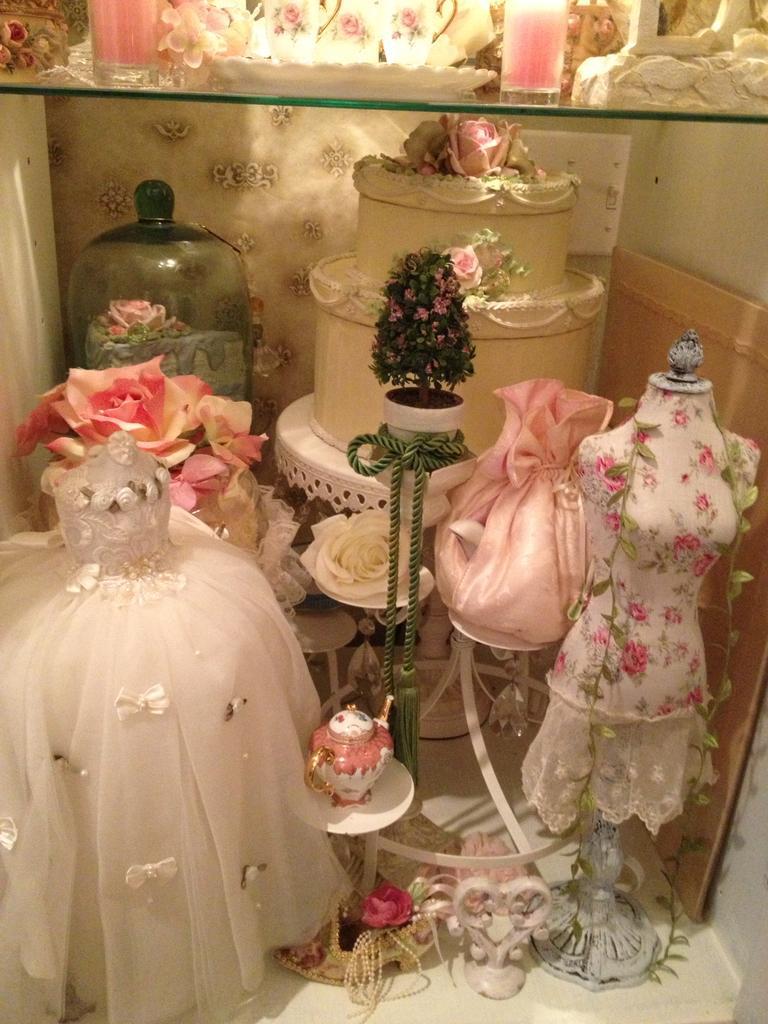In one or two sentences, can you explain what this image depicts? In this image there are frocks. In the center of the image there is a table and on top of the table there is a depiction of cake. There is a glass platform. On top of it there are glasses and a few other objects. In the background of the image there is a wall. At the bottom of the image there is a floor. 